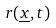Convert formula to latex. <formula><loc_0><loc_0><loc_500><loc_500>r ( \underline { x } , t )</formula> 